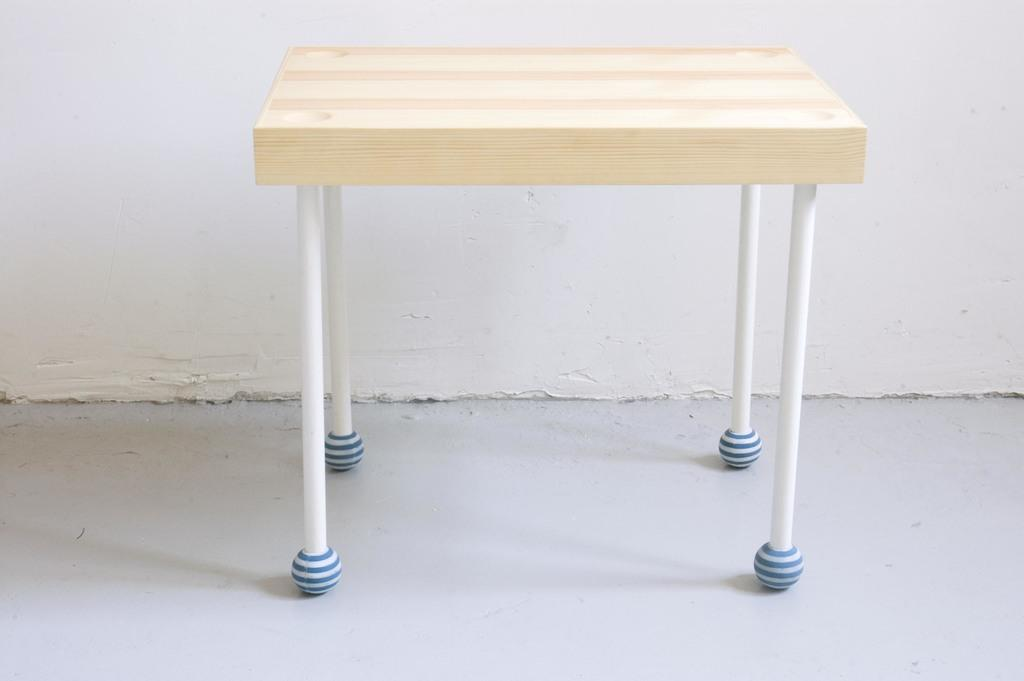What type of furniture is present in the image? There is a table in the image. What is unique about the table's surface? The table has rods on its surface. What can be seen in the background of the image? There is a white wall in the background of the image. What type of food is being prepared on the table in the image? There is no food visible in the image, and the table does not appear to be used for food preparation. 